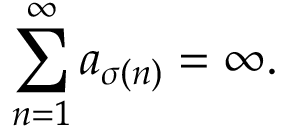Convert formula to latex. <formula><loc_0><loc_0><loc_500><loc_500>\sum _ { n = 1 } ^ { \infty } a _ { \sigma ( n ) } = \infty .</formula> 